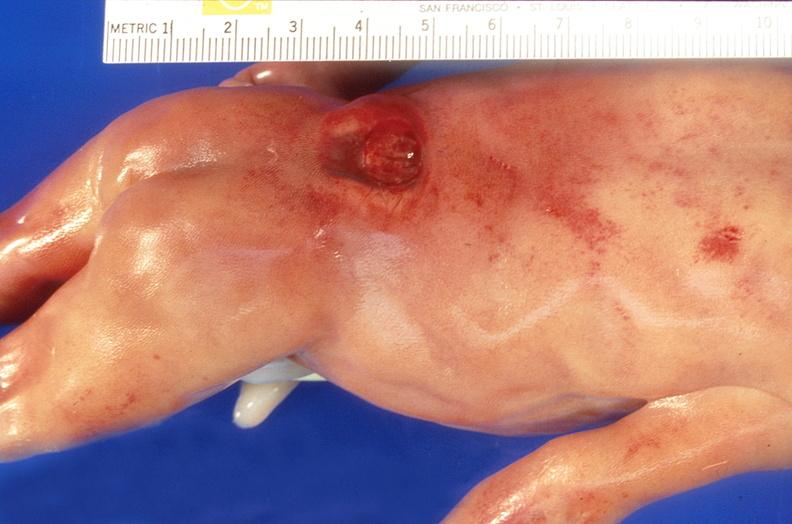what does this image show?
Answer the question using a single word or phrase. Neural tube defect 